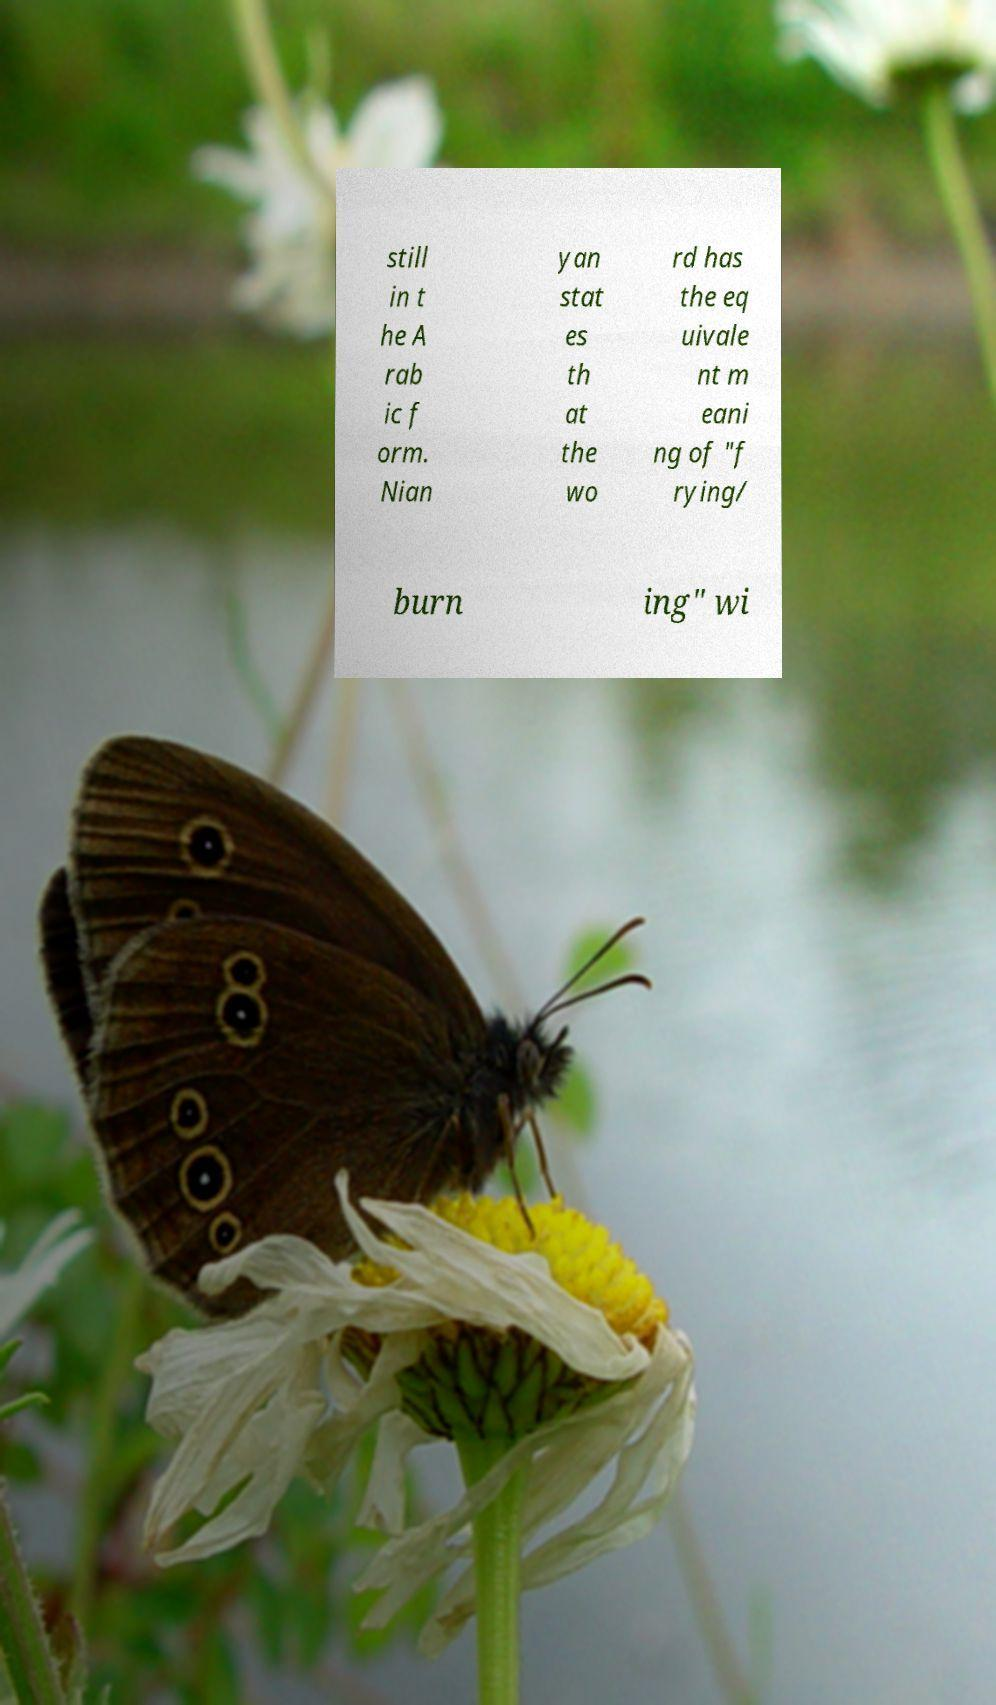Can you accurately transcribe the text from the provided image for me? still in t he A rab ic f orm. Nian yan stat es th at the wo rd has the eq uivale nt m eani ng of "f rying/ burn ing" wi 